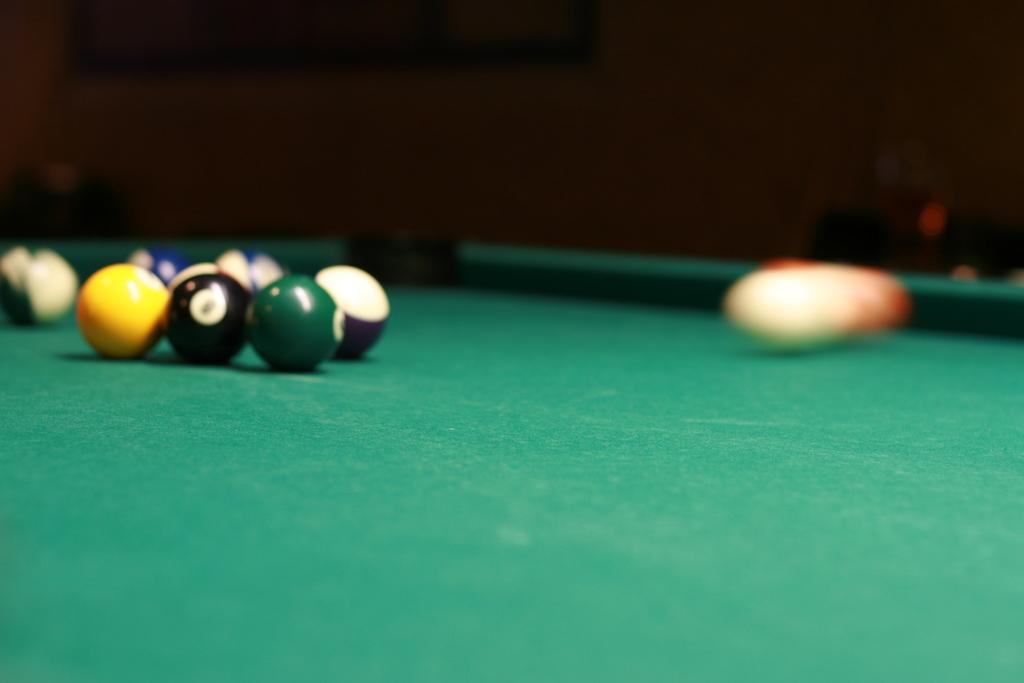What is on the pool table in the image? There are balls on a pool table in the image. Can you describe the background of the image? The background of the image is blurry. What type of pie is being served on the pool table in the image? There is no pie present in the image; it features a pool table with balls on it. How does the wealth of the players affect their performance in the game in the image? There is no indication of the players' wealth or their performance in the game in the image. 